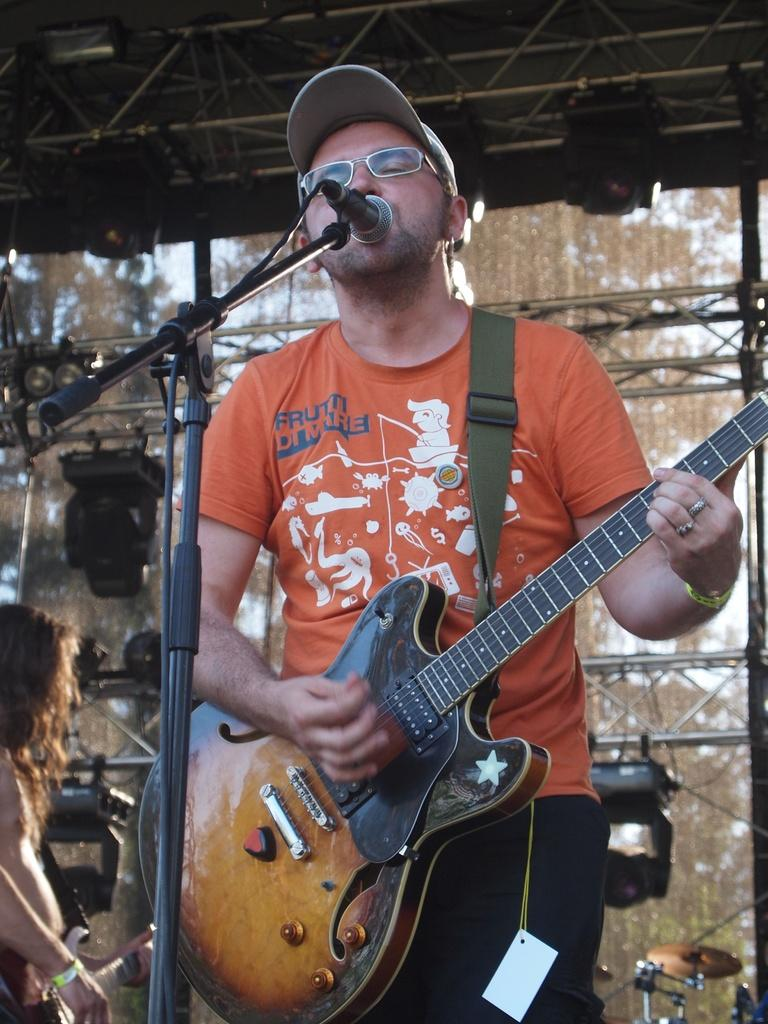Who is the main subject in the image? There is a man in the center of the image. What is the man doing in the image? The man is playing the guitar. What object is in front of the man? There is a microphone in front of the man. What else can be seen in the image related to music? There are musical instruments in the background of the image. Where is the umbrella placed in the image? There is no umbrella present in the image. What type of throne does the man sit on while playing the guitar? The man is standing, not sitting on a throne, while playing the guitar. 